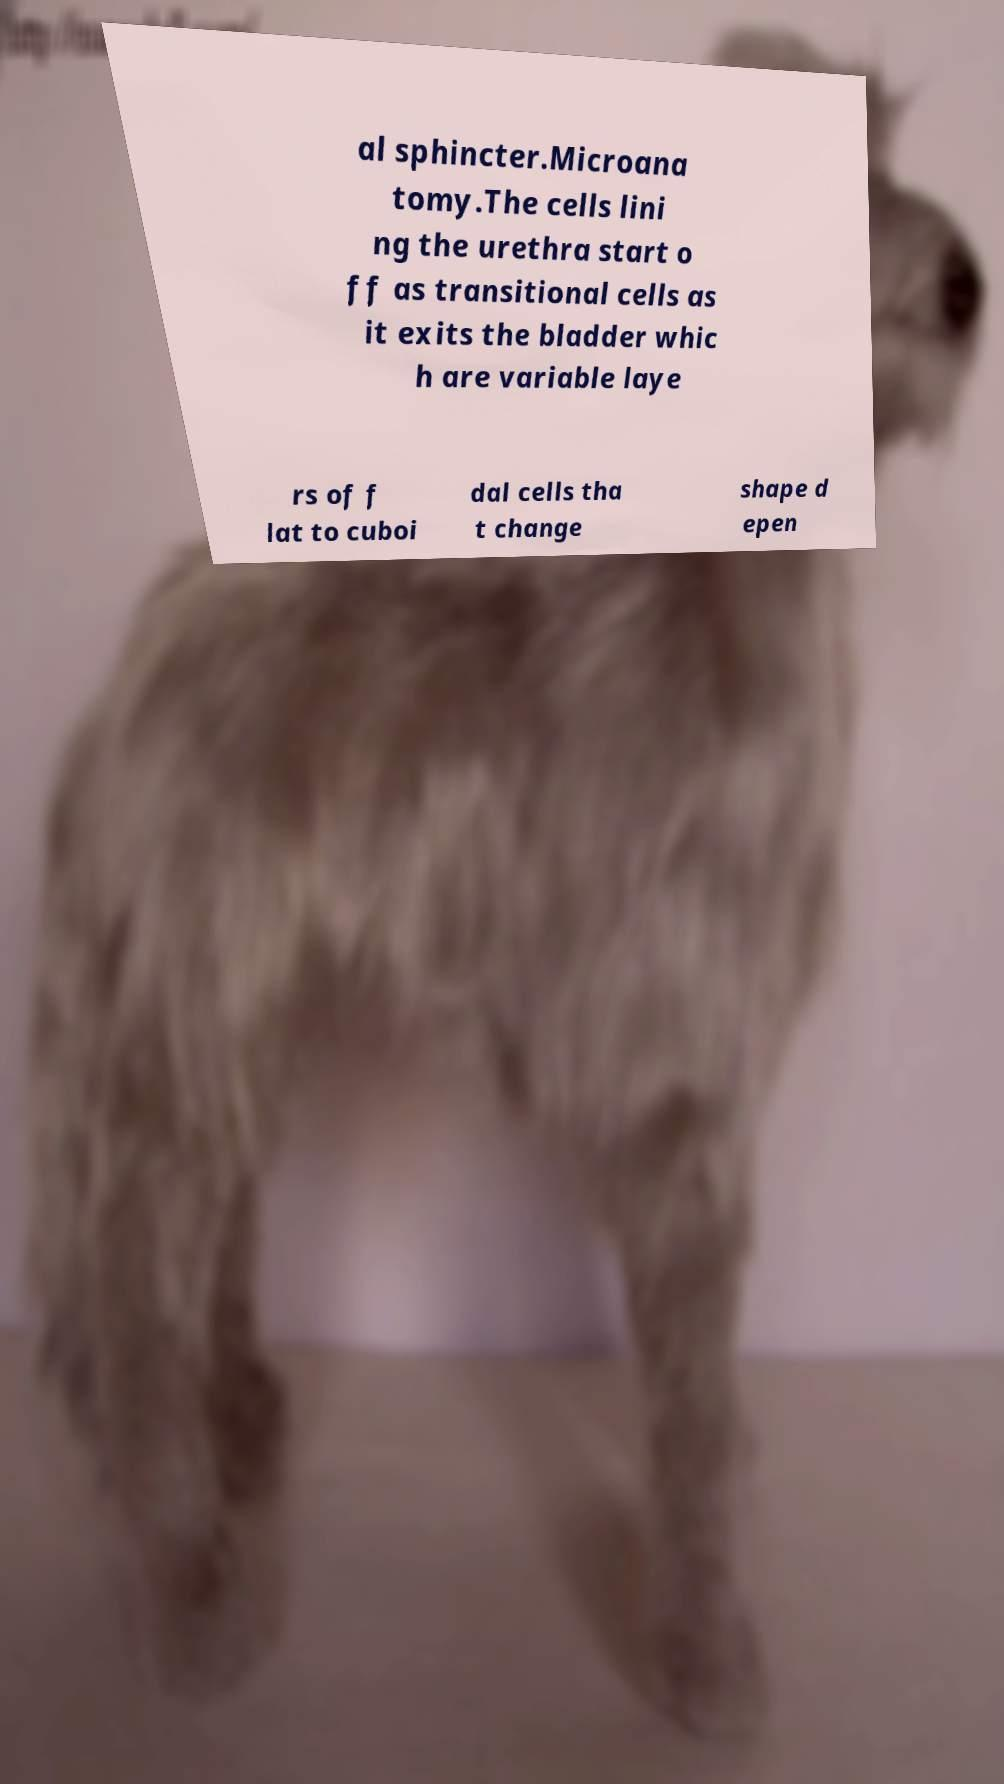I need the written content from this picture converted into text. Can you do that? al sphincter.Microana tomy.The cells lini ng the urethra start o ff as transitional cells as it exits the bladder whic h are variable laye rs of f lat to cuboi dal cells tha t change shape d epen 